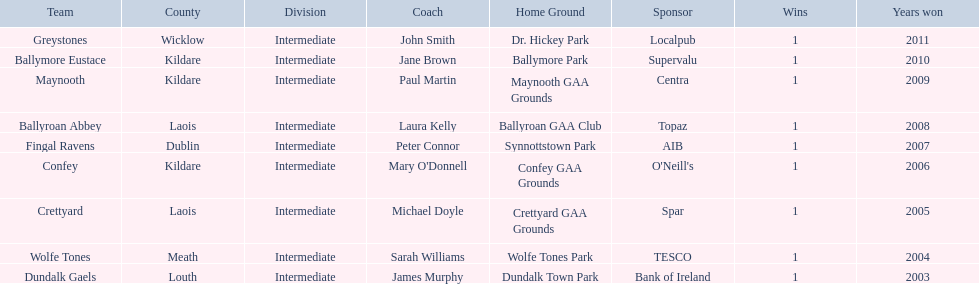What is the number of wins for confey 1. 